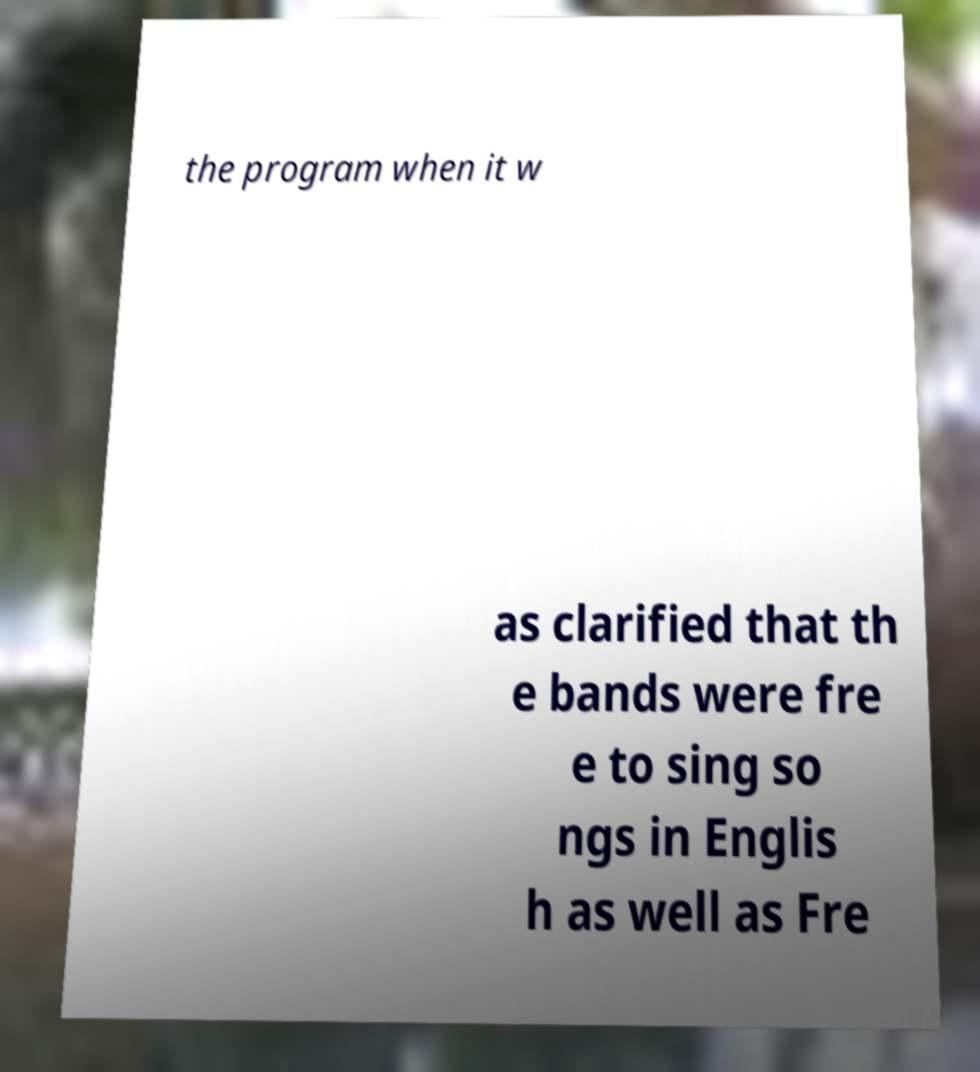Can you accurately transcribe the text from the provided image for me? the program when it w as clarified that th e bands were fre e to sing so ngs in Englis h as well as Fre 